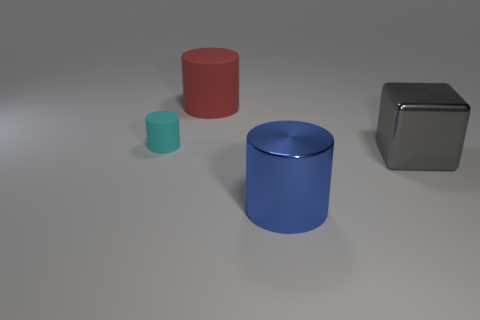Add 2 small green shiny cylinders. How many objects exist? 6 Subtract all blocks. How many objects are left? 3 Subtract all small matte cylinders. Subtract all small cyan objects. How many objects are left? 2 Add 2 big gray metallic cubes. How many big gray metallic cubes are left? 3 Add 2 red things. How many red things exist? 3 Subtract 0 brown blocks. How many objects are left? 4 